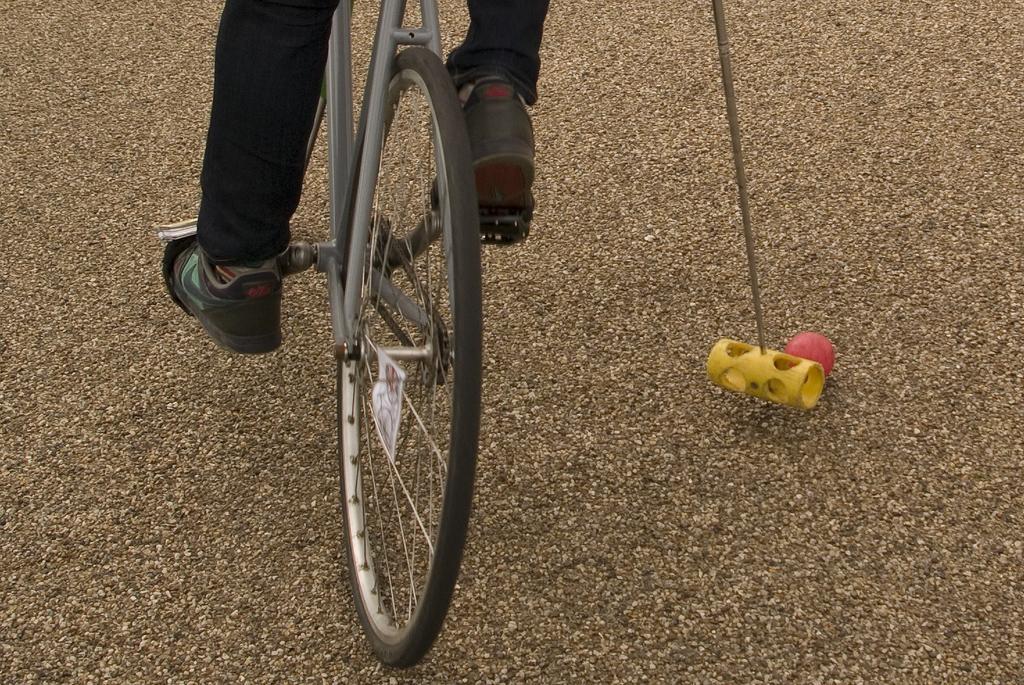Describe this image in one or two sentences. There is a person in black color pant, holding a stick and cycling on the ground, near a red ball, which is on the ground. 